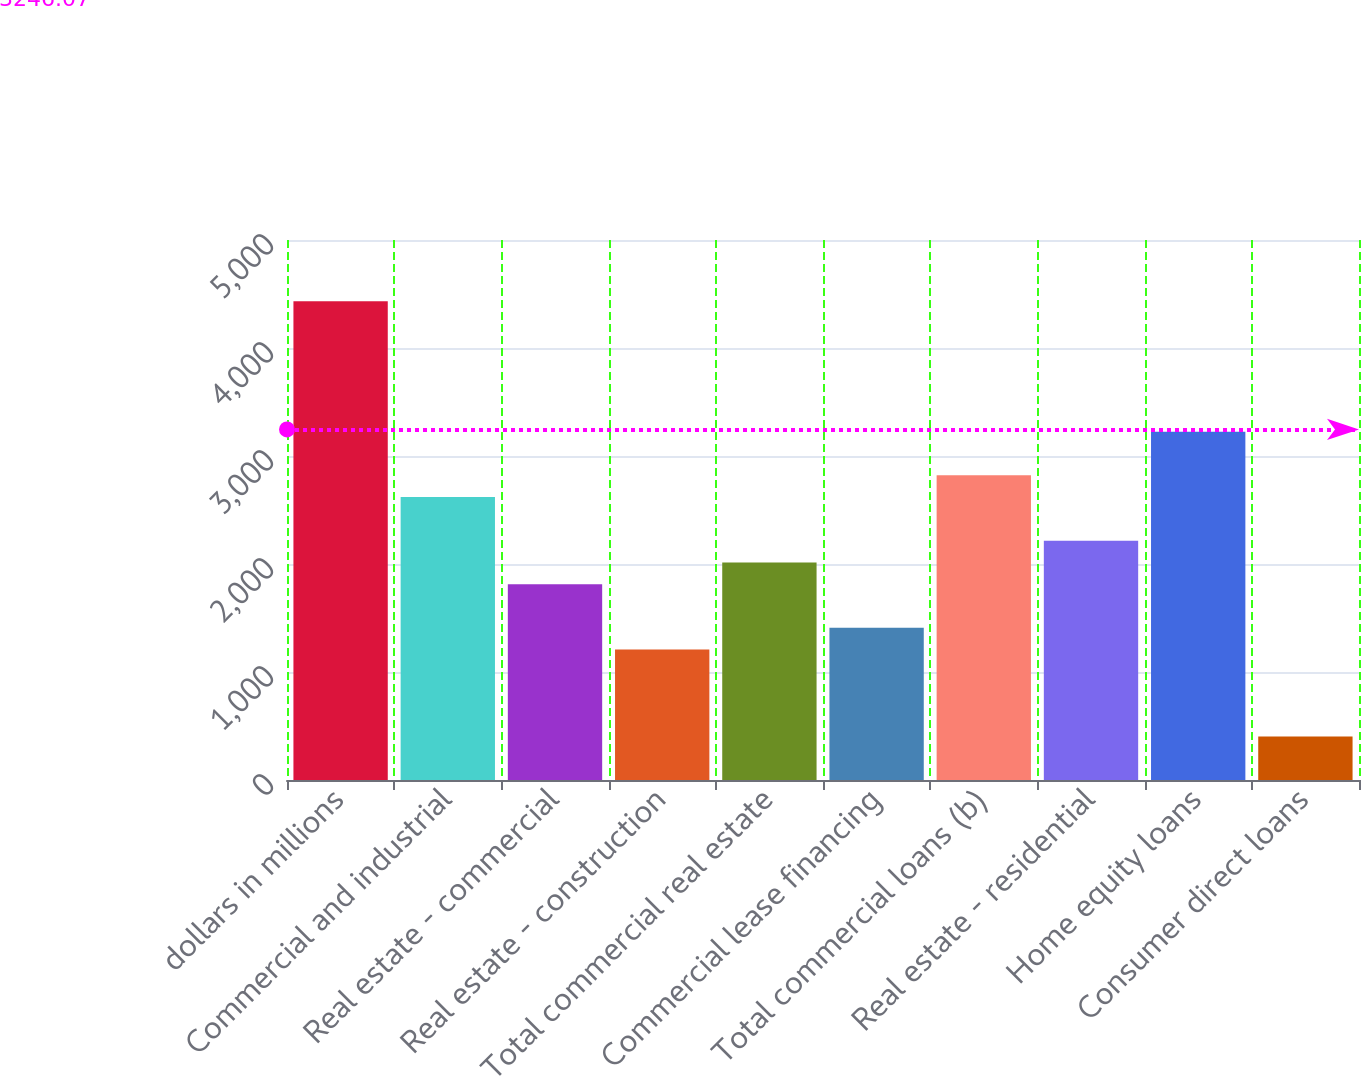<chart> <loc_0><loc_0><loc_500><loc_500><bar_chart><fcel>dollars in millions<fcel>Commercial and industrial<fcel>Real estate - commercial<fcel>Real estate - construction<fcel>Total commercial real estate<fcel>Commercial lease financing<fcel>Total commercial loans (b)<fcel>Real estate - residential<fcel>Home equity loans<fcel>Consumer direct loans<nl><fcel>4432.22<fcel>2619.28<fcel>1813.55<fcel>1209.26<fcel>2014.98<fcel>1410.69<fcel>2820.72<fcel>2216.41<fcel>3223.59<fcel>403.52<nl></chart> 